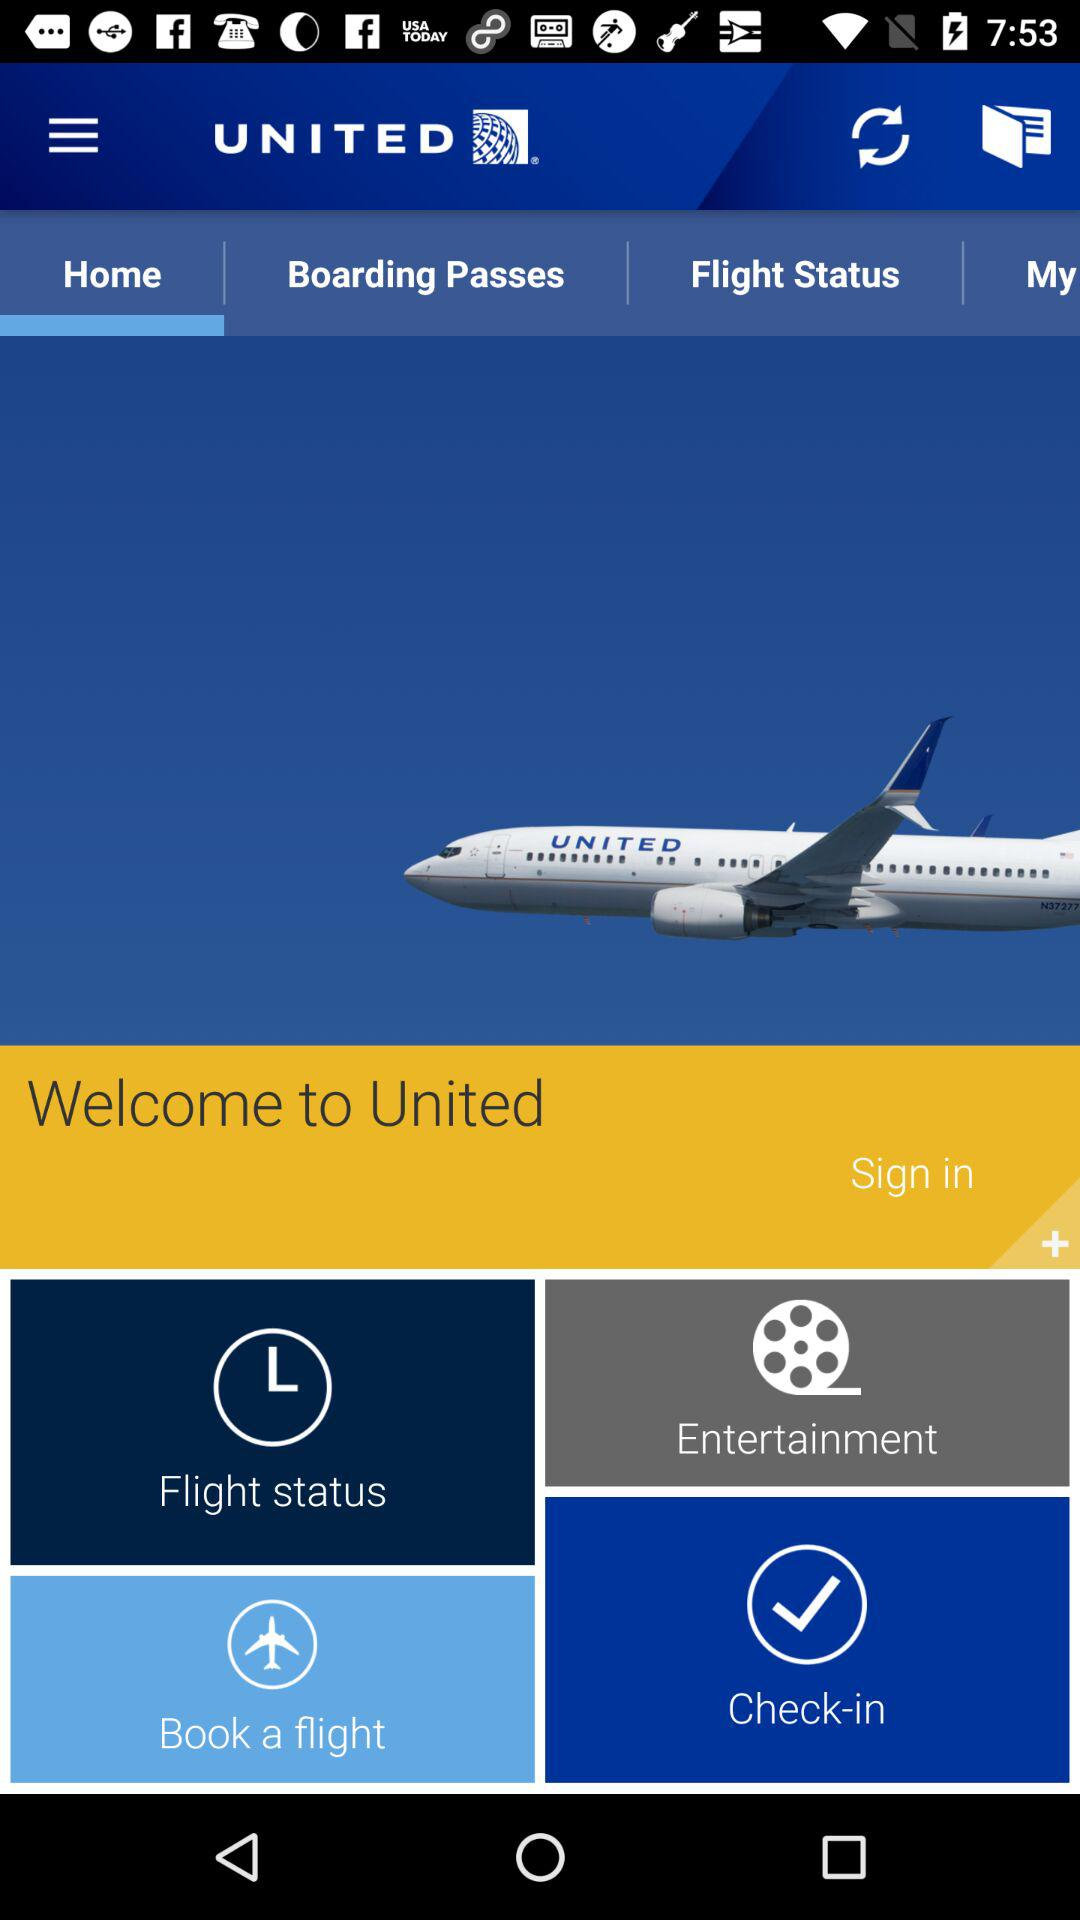Which tab is currently selected? The currently selected tab is "Home". 